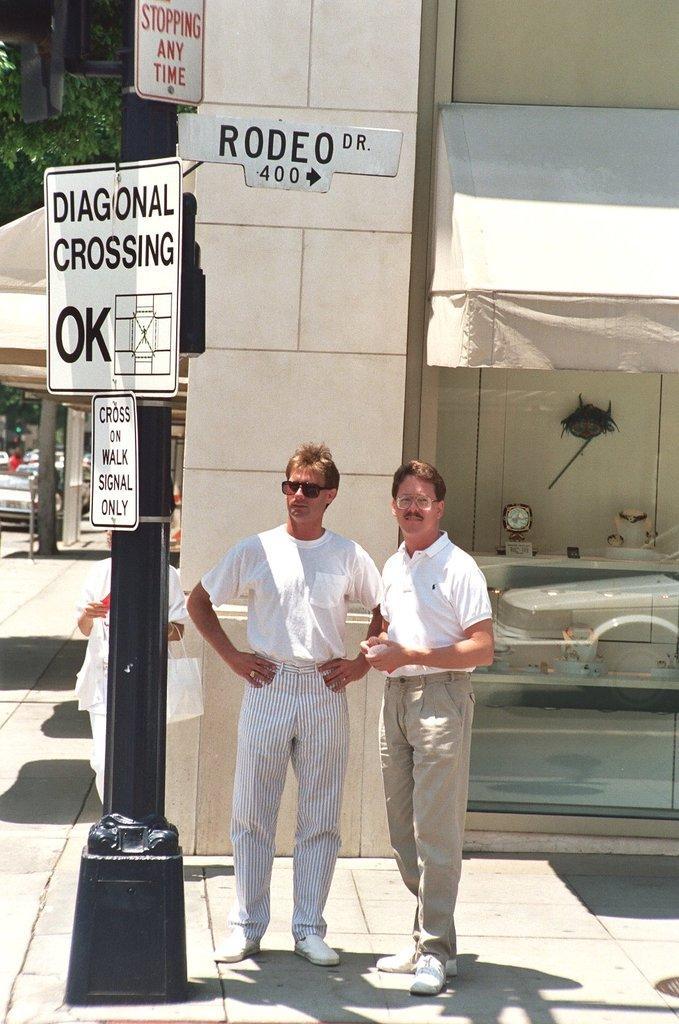Can you describe this image briefly? In this picture I can observe two men standing in the middle of the picture. On the left side I can observe a pole to which white color boards are fixed. Behind them I can observe a building. 